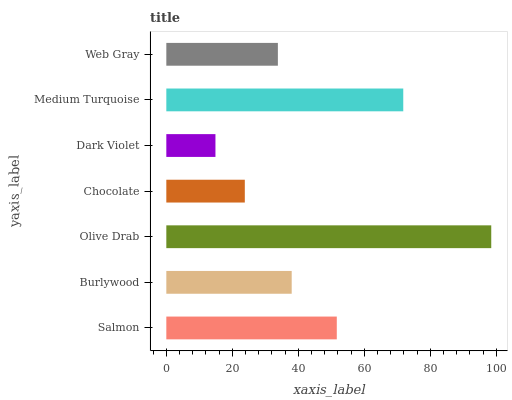Is Dark Violet the minimum?
Answer yes or no. Yes. Is Olive Drab the maximum?
Answer yes or no. Yes. Is Burlywood the minimum?
Answer yes or no. No. Is Burlywood the maximum?
Answer yes or no. No. Is Salmon greater than Burlywood?
Answer yes or no. Yes. Is Burlywood less than Salmon?
Answer yes or no. Yes. Is Burlywood greater than Salmon?
Answer yes or no. No. Is Salmon less than Burlywood?
Answer yes or no. No. Is Burlywood the high median?
Answer yes or no. Yes. Is Burlywood the low median?
Answer yes or no. Yes. Is Dark Violet the high median?
Answer yes or no. No. Is Chocolate the low median?
Answer yes or no. No. 